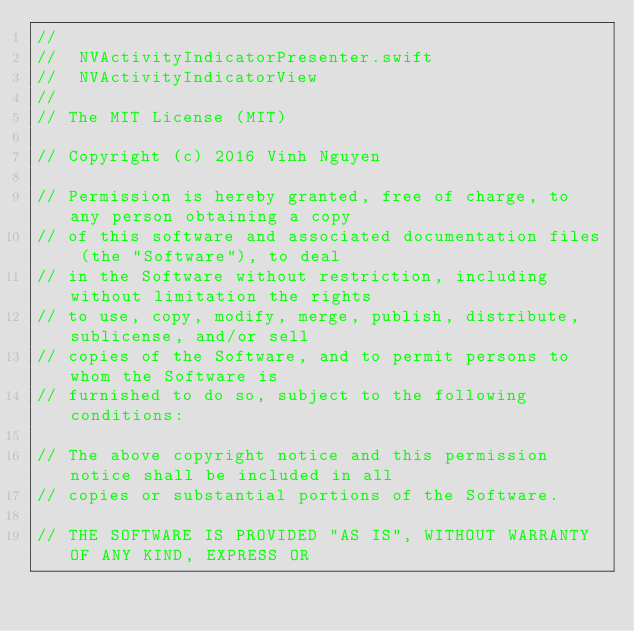<code> <loc_0><loc_0><loc_500><loc_500><_Swift_>//
//  NVActivityIndicatorPresenter.swift
//  NVActivityIndicatorView
//
// The MIT License (MIT)

// Copyright (c) 2016 Vinh Nguyen

// Permission is hereby granted, free of charge, to any person obtaining a copy
// of this software and associated documentation files (the "Software"), to deal
// in the Software without restriction, including without limitation the rights
// to use, copy, modify, merge, publish, distribute, sublicense, and/or sell
// copies of the Software, and to permit persons to whom the Software is
// furnished to do so, subject to the following conditions:

// The above copyright notice and this permission notice shall be included in all
// copies or substantial portions of the Software.

// THE SOFTWARE IS PROVIDED "AS IS", WITHOUT WARRANTY OF ANY KIND, EXPRESS OR</code> 